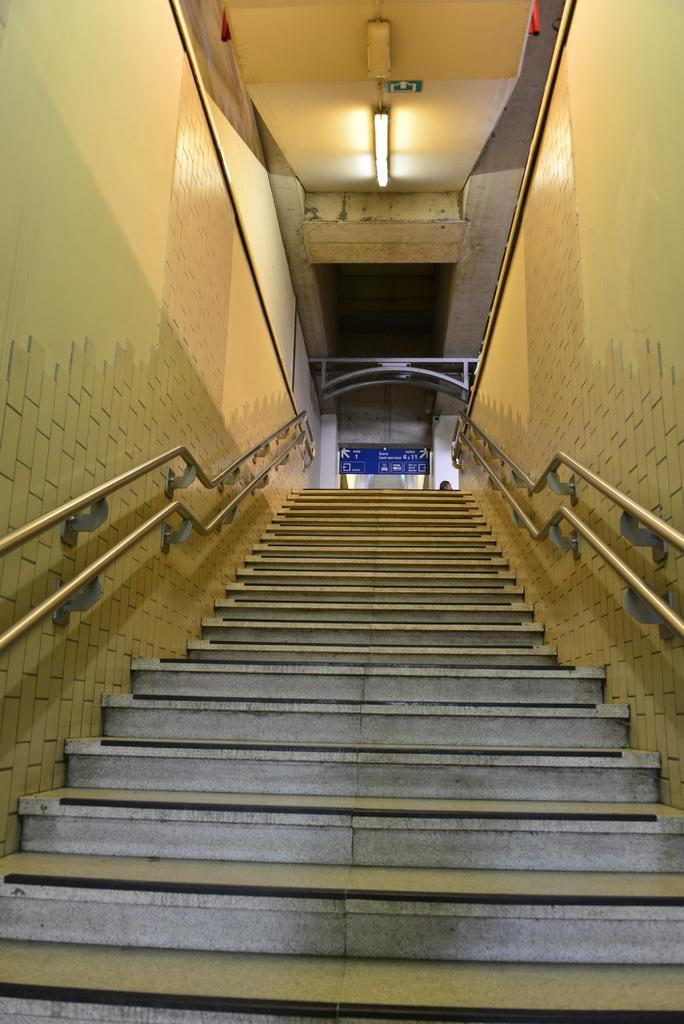Please provide a concise description of this image. In this picture I can see the stairs in front and I see the railings on the sides and I see the walls. In the background I see the light on the ceiling. 